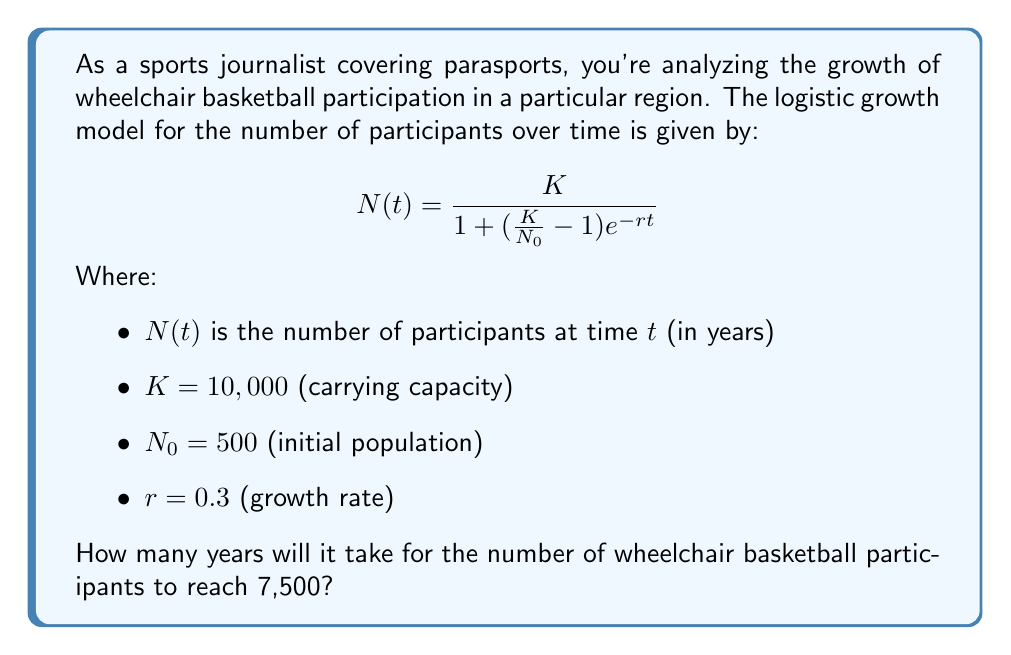What is the answer to this math problem? To solve this problem, we need to use the logistic growth model equation and solve for $t$ when $N(t) = 7,500$. Let's approach this step-by-step:

1) We start with the logistic growth equation:
   $$N(t) = \frac{K}{1 + (\frac{K}{N_0} - 1)e^{-rt}}$$

2) Substitute the known values:
   $$7,500 = \frac{10,000}{1 + (\frac{10,000}{500} - 1)e^{-0.3t}}$$

3) Simplify:
   $$7,500 = \frac{10,000}{1 + 19e^{-0.3t}}$$

4) Multiply both sides by the denominator:
   $$7,500(1 + 19e^{-0.3t}) = 10,000$$

5) Expand:
   $$7,500 + 142,500e^{-0.3t} = 10,000$$

6) Subtract 7,500 from both sides:
   $$142,500e^{-0.3t} = 2,500$$

7) Divide both sides by 142,500:
   $$e^{-0.3t} = \frac{2,500}{142,500} = \frac{1}{57}$$

8) Take the natural log of both sides:
   $$-0.3t = \ln(\frac{1}{57})$$

9) Divide both sides by -0.3:
   $$t = -\frac{\ln(\frac{1}{57})}{0.3} = \frac{\ln(57)}{0.3}$$

10) Calculate the final value:
    $$t \approx 13.45$$

Therefore, it will take approximately 13.45 years for the number of wheelchair basketball participants to reach 7,500.
Answer: 13.45 years 